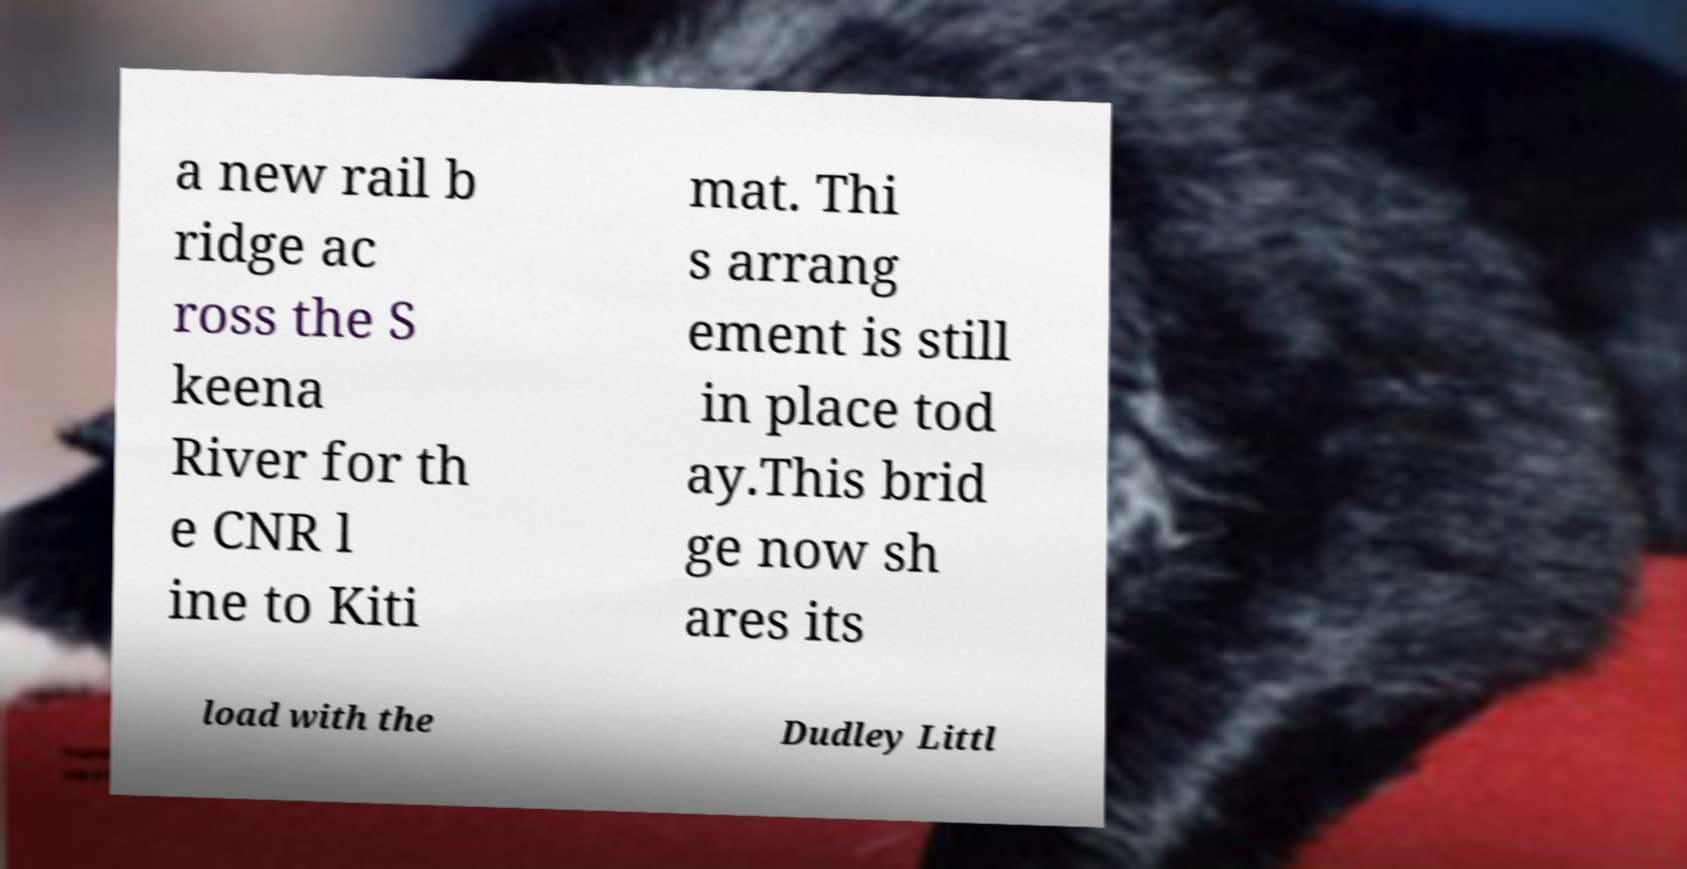There's text embedded in this image that I need extracted. Can you transcribe it verbatim? a new rail b ridge ac ross the S keena River for th e CNR l ine to Kiti mat. Thi s arrang ement is still in place tod ay.This brid ge now sh ares its load with the Dudley Littl 